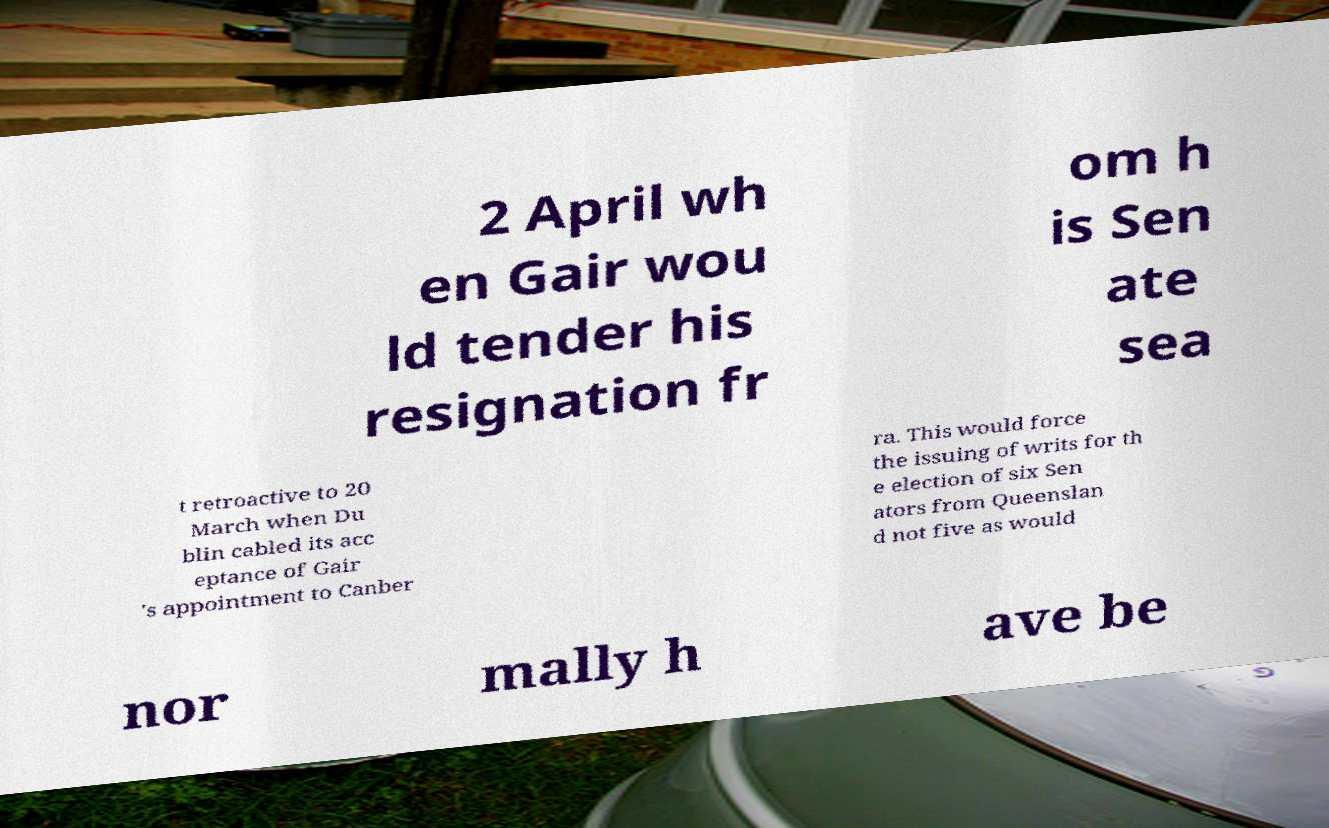There's text embedded in this image that I need extracted. Can you transcribe it verbatim? 2 April wh en Gair wou ld tender his resignation fr om h is Sen ate sea t retroactive to 20 March when Du blin cabled its acc eptance of Gair 's appointment to Canber ra. This would force the issuing of writs for th e election of six Sen ators from Queenslan d not five as would nor mally h ave be 